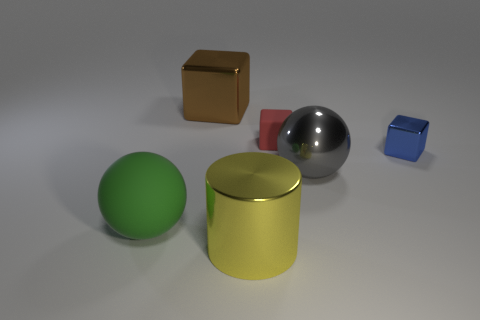Do the ball on the right side of the green matte object and the metal thing in front of the big rubber object have the same size?
Ensure brevity in your answer.  Yes. Is the number of large shiny things greater than the number of gray matte objects?
Your answer should be very brief. Yes. What number of blue blocks are made of the same material as the large gray sphere?
Give a very brief answer. 1. Is the shape of the yellow metallic thing the same as the tiny blue object?
Provide a short and direct response. No. What size is the block that is right of the ball on the right side of the big metal thing in front of the green thing?
Your answer should be compact. Small. There is a metallic cube that is on the left side of the red object; are there any green spheres that are behind it?
Your answer should be compact. No. There is a cylinder in front of the matte object that is in front of the blue metallic object; how many small metal things are on the left side of it?
Offer a very short reply. 0. What is the color of the large metal object that is in front of the tiny metal thing and behind the green ball?
Make the answer very short. Gray. How many cylinders are the same color as the tiny matte thing?
Ensure brevity in your answer.  0. What number of cubes are either tiny rubber things or small blue objects?
Your response must be concise. 2. 